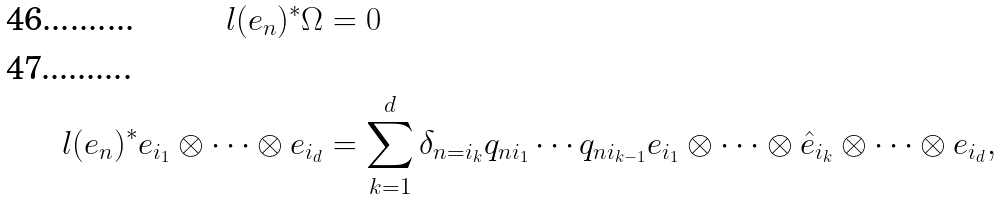Convert formula to latex. <formula><loc_0><loc_0><loc_500><loc_500>l ( e _ { n } ) ^ { * } \Omega & = 0 \\ l ( e _ { n } ) ^ { * } e _ { i _ { 1 } } \otimes \cdots \otimes e _ { i _ { d } } & = \sum _ { k = 1 } ^ { d } \delta _ { n = i _ { k } } q _ { n i _ { 1 } } \cdots q _ { n i _ { k - 1 } } e _ { i _ { 1 } } \otimes \cdots \otimes \hat { e } _ { i _ { k } } \otimes \cdots \otimes e _ { i _ { d } } ,</formula> 